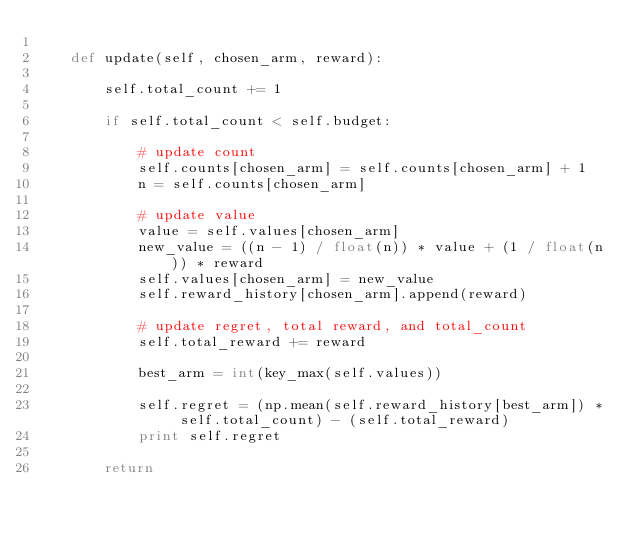Convert code to text. <code><loc_0><loc_0><loc_500><loc_500><_Python_>
    def update(self, chosen_arm, reward):

        self.total_count += 1

        if self.total_count < self.budget:

            # update count
            self.counts[chosen_arm] = self.counts[chosen_arm] + 1
            n = self.counts[chosen_arm]

            # update value
            value = self.values[chosen_arm]
            new_value = ((n - 1) / float(n)) * value + (1 / float(n)) * reward
            self.values[chosen_arm] = new_value
            self.reward_history[chosen_arm].append(reward)

            # update regret, total reward, and total_count
            self.total_reward += reward

            best_arm = int(key_max(self.values))

            self.regret = (np.mean(self.reward_history[best_arm]) * self.total_count) - (self.total_reward)
            print self.regret

        return 
</code> 